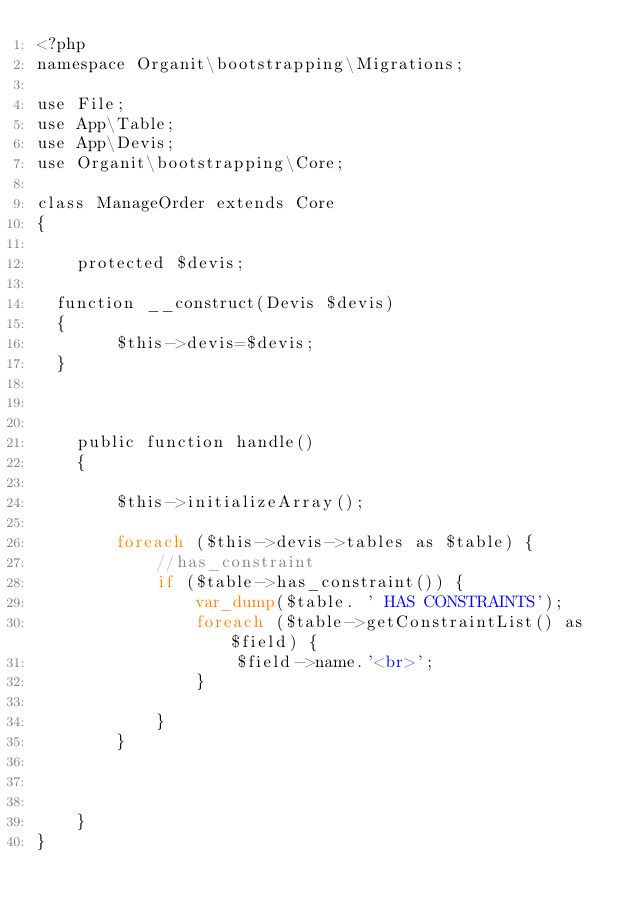<code> <loc_0><loc_0><loc_500><loc_500><_PHP_><?php
namespace Organit\bootstrapping\Migrations;

use File;
use App\Table;
use App\Devis;
use Organit\bootstrapping\Core;

class ManageOrder extends Core
{

    protected $devis;

	function __construct(Devis $devis)
	{
        $this->devis=$devis;
	}



    public function handle()
    {

        $this->initializeArray();

        foreach ($this->devis->tables as $table) {
            //has_constraint
            if ($table->has_constraint()) {
                var_dump($table. ' HAS CONSTRAINTS');
                foreach ($table->getConstraintList() as $field) {
                    $field->name.'<br>';
                }

            }
        }



    }
}
</code> 